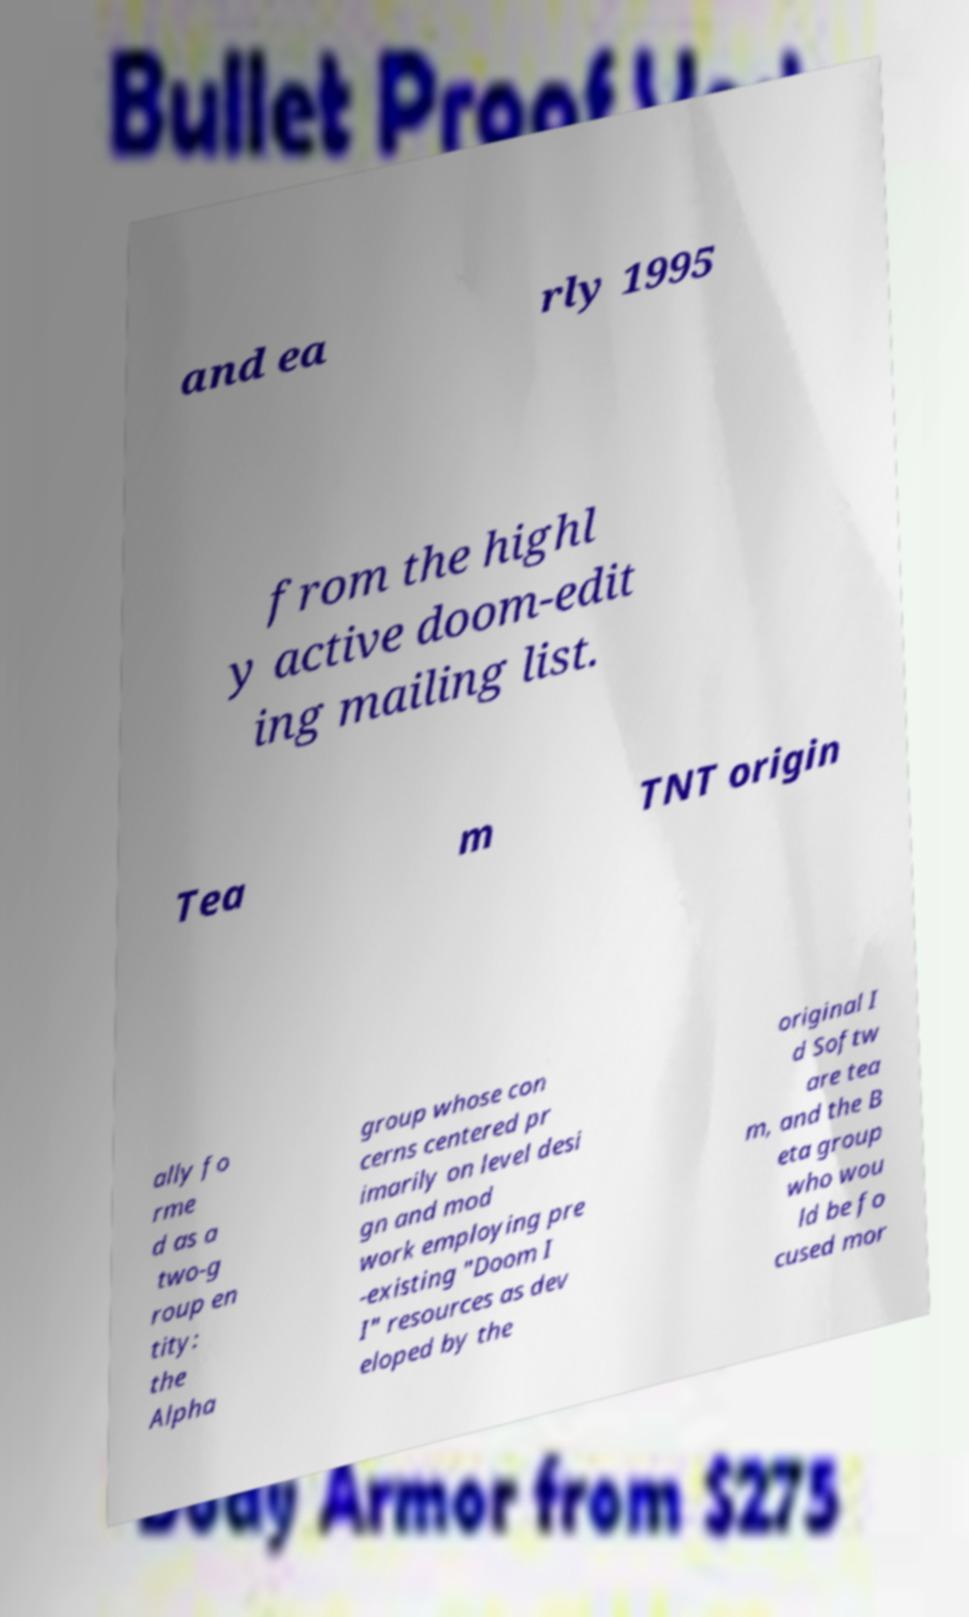Can you accurately transcribe the text from the provided image for me? and ea rly 1995 from the highl y active doom-edit ing mailing list. Tea m TNT origin ally fo rme d as a two-g roup en tity: the Alpha group whose con cerns centered pr imarily on level desi gn and mod work employing pre -existing "Doom I I" resources as dev eloped by the original I d Softw are tea m, and the B eta group who wou ld be fo cused mor 